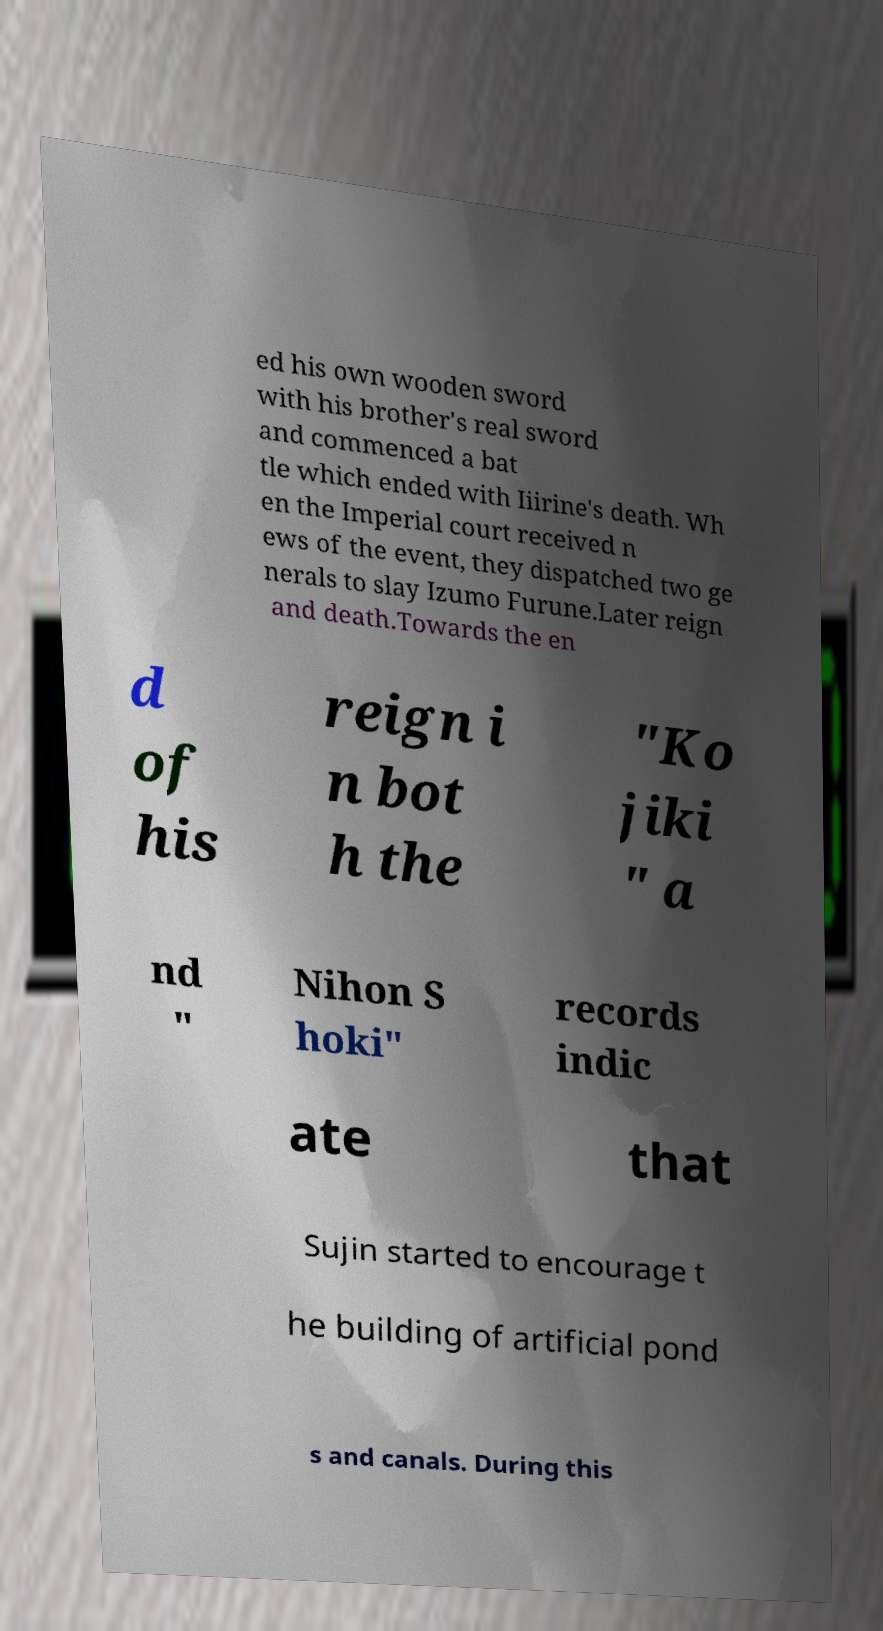There's text embedded in this image that I need extracted. Can you transcribe it verbatim? ed his own wooden sword with his brother's real sword and commenced a bat tle which ended with Iiirine's death. Wh en the Imperial court received n ews of the event, they dispatched two ge nerals to slay Izumo Furune.Later reign and death.Towards the en d of his reign i n bot h the "Ko jiki " a nd " Nihon S hoki" records indic ate that Sujin started to encourage t he building of artificial pond s and canals. During this 